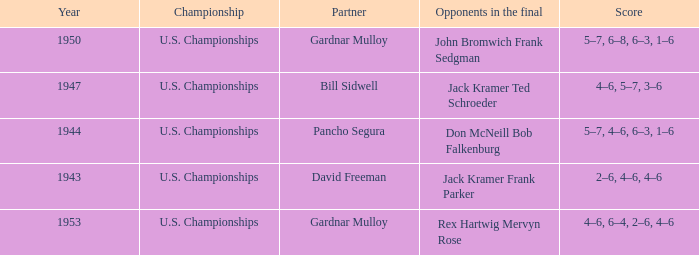Which Championship has a Score of 2–6, 4–6, 4–6? U.S. Championships. 